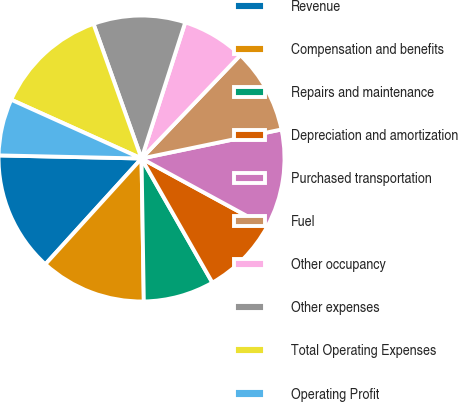<chart> <loc_0><loc_0><loc_500><loc_500><pie_chart><fcel>Revenue<fcel>Compensation and benefits<fcel>Repairs and maintenance<fcel>Depreciation and amortization<fcel>Purchased transportation<fcel>Fuel<fcel>Other occupancy<fcel>Other expenses<fcel>Total Operating Expenses<fcel>Operating Profit<nl><fcel>13.6%<fcel>12.0%<fcel>8.0%<fcel>8.8%<fcel>11.2%<fcel>9.6%<fcel>7.2%<fcel>10.4%<fcel>12.8%<fcel>6.4%<nl></chart> 